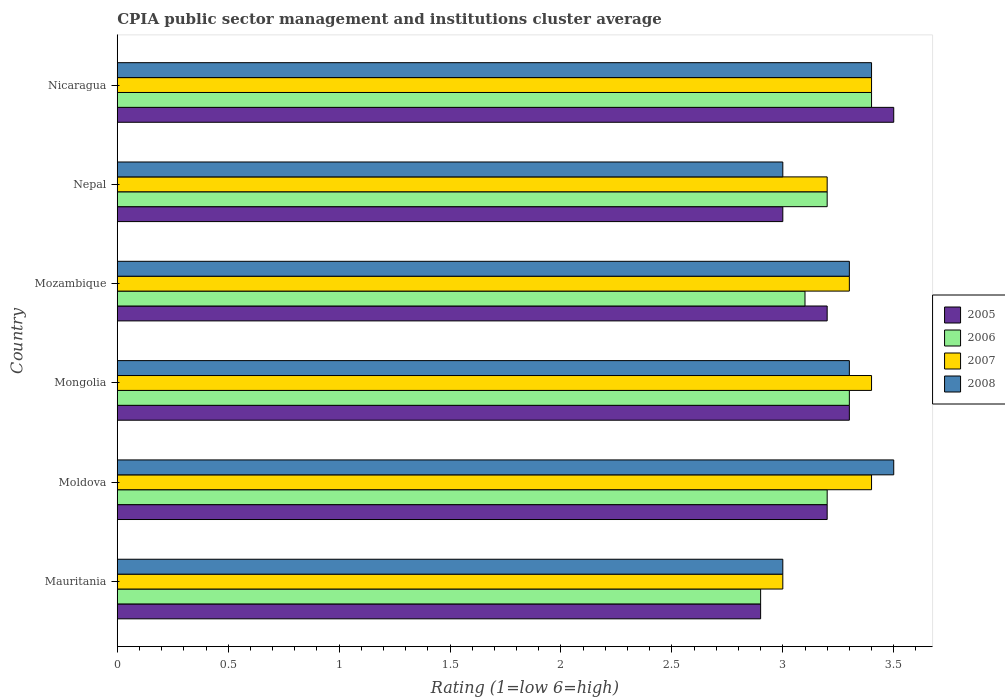How many different coloured bars are there?
Give a very brief answer. 4. Are the number of bars per tick equal to the number of legend labels?
Keep it short and to the point. Yes. Are the number of bars on each tick of the Y-axis equal?
Keep it short and to the point. Yes. How many bars are there on the 6th tick from the top?
Provide a succinct answer. 4. What is the label of the 1st group of bars from the top?
Offer a very short reply. Nicaragua. What is the CPIA rating in 2008 in Mozambique?
Make the answer very short. 3.3. Across all countries, what is the maximum CPIA rating in 2006?
Your answer should be very brief. 3.4. In which country was the CPIA rating in 2008 maximum?
Offer a terse response. Moldova. In which country was the CPIA rating in 2005 minimum?
Offer a terse response. Mauritania. What is the total CPIA rating in 2005 in the graph?
Keep it short and to the point. 19.1. What is the difference between the CPIA rating in 2008 in Mozambique and the CPIA rating in 2007 in Mauritania?
Give a very brief answer. 0.3. What is the average CPIA rating in 2006 per country?
Ensure brevity in your answer.  3.18. What is the ratio of the CPIA rating in 2006 in Moldova to that in Nicaragua?
Offer a very short reply. 0.94. Is it the case that in every country, the sum of the CPIA rating in 2005 and CPIA rating in 2008 is greater than the sum of CPIA rating in 2007 and CPIA rating in 2006?
Ensure brevity in your answer.  No. Is it the case that in every country, the sum of the CPIA rating in 2007 and CPIA rating in 2008 is greater than the CPIA rating in 2005?
Make the answer very short. Yes. Are the values on the major ticks of X-axis written in scientific E-notation?
Ensure brevity in your answer.  No. Does the graph contain any zero values?
Provide a succinct answer. No. How many legend labels are there?
Your answer should be compact. 4. How are the legend labels stacked?
Keep it short and to the point. Vertical. What is the title of the graph?
Give a very brief answer. CPIA public sector management and institutions cluster average. What is the label or title of the X-axis?
Your response must be concise. Rating (1=low 6=high). What is the label or title of the Y-axis?
Provide a short and direct response. Country. What is the Rating (1=low 6=high) of 2005 in Moldova?
Give a very brief answer. 3.2. What is the Rating (1=low 6=high) in 2007 in Moldova?
Ensure brevity in your answer.  3.4. What is the Rating (1=low 6=high) in 2005 in Mongolia?
Make the answer very short. 3.3. What is the Rating (1=low 6=high) in 2006 in Mongolia?
Give a very brief answer. 3.3. What is the Rating (1=low 6=high) in 2005 in Mozambique?
Provide a short and direct response. 3.2. What is the Rating (1=low 6=high) of 2007 in Mozambique?
Give a very brief answer. 3.3. What is the Rating (1=low 6=high) of 2005 in Nepal?
Keep it short and to the point. 3. What is the Rating (1=low 6=high) of 2006 in Nepal?
Make the answer very short. 3.2. What is the Rating (1=low 6=high) of 2007 in Nepal?
Your answer should be very brief. 3.2. What is the Rating (1=low 6=high) in 2008 in Nepal?
Offer a very short reply. 3. What is the Rating (1=low 6=high) in 2007 in Nicaragua?
Make the answer very short. 3.4. What is the Rating (1=low 6=high) in 2008 in Nicaragua?
Offer a very short reply. 3.4. Across all countries, what is the maximum Rating (1=low 6=high) of 2005?
Offer a very short reply. 3.5. Across all countries, what is the maximum Rating (1=low 6=high) in 2006?
Ensure brevity in your answer.  3.4. Across all countries, what is the maximum Rating (1=low 6=high) in 2007?
Your answer should be very brief. 3.4. Across all countries, what is the minimum Rating (1=low 6=high) in 2005?
Provide a short and direct response. 2.9. Across all countries, what is the minimum Rating (1=low 6=high) of 2006?
Make the answer very short. 2.9. What is the total Rating (1=low 6=high) of 2007 in the graph?
Your answer should be very brief. 19.7. What is the total Rating (1=low 6=high) of 2008 in the graph?
Give a very brief answer. 19.5. What is the difference between the Rating (1=low 6=high) in 2007 in Mauritania and that in Moldova?
Ensure brevity in your answer.  -0.4. What is the difference between the Rating (1=low 6=high) in 2005 in Mauritania and that in Mongolia?
Ensure brevity in your answer.  -0.4. What is the difference between the Rating (1=low 6=high) of 2006 in Mauritania and that in Mongolia?
Your response must be concise. -0.4. What is the difference between the Rating (1=low 6=high) of 2008 in Mauritania and that in Mozambique?
Offer a terse response. -0.3. What is the difference between the Rating (1=low 6=high) of 2005 in Mauritania and that in Nepal?
Your answer should be very brief. -0.1. What is the difference between the Rating (1=low 6=high) of 2006 in Mauritania and that in Nicaragua?
Provide a succinct answer. -0.5. What is the difference between the Rating (1=low 6=high) in 2007 in Mauritania and that in Nicaragua?
Give a very brief answer. -0.4. What is the difference between the Rating (1=low 6=high) of 2008 in Mauritania and that in Nicaragua?
Offer a very short reply. -0.4. What is the difference between the Rating (1=low 6=high) in 2005 in Moldova and that in Mongolia?
Your response must be concise. -0.1. What is the difference between the Rating (1=low 6=high) of 2006 in Moldova and that in Mongolia?
Offer a terse response. -0.1. What is the difference between the Rating (1=low 6=high) of 2007 in Moldova and that in Mongolia?
Provide a succinct answer. 0. What is the difference between the Rating (1=low 6=high) in 2005 in Moldova and that in Mozambique?
Keep it short and to the point. 0. What is the difference between the Rating (1=low 6=high) of 2008 in Moldova and that in Mozambique?
Give a very brief answer. 0.2. What is the difference between the Rating (1=low 6=high) of 2005 in Moldova and that in Nicaragua?
Provide a succinct answer. -0.3. What is the difference between the Rating (1=low 6=high) in 2006 in Moldova and that in Nicaragua?
Offer a very short reply. -0.2. What is the difference between the Rating (1=low 6=high) in 2007 in Moldova and that in Nicaragua?
Offer a very short reply. 0. What is the difference between the Rating (1=low 6=high) of 2005 in Mongolia and that in Mozambique?
Your answer should be very brief. 0.1. What is the difference between the Rating (1=low 6=high) of 2007 in Mongolia and that in Mozambique?
Provide a succinct answer. 0.1. What is the difference between the Rating (1=low 6=high) in 2008 in Mongolia and that in Mozambique?
Make the answer very short. 0. What is the difference between the Rating (1=low 6=high) of 2005 in Mongolia and that in Nepal?
Provide a succinct answer. 0.3. What is the difference between the Rating (1=low 6=high) in 2008 in Mongolia and that in Nepal?
Keep it short and to the point. 0.3. What is the difference between the Rating (1=low 6=high) in 2006 in Mongolia and that in Nicaragua?
Provide a short and direct response. -0.1. What is the difference between the Rating (1=low 6=high) of 2007 in Mongolia and that in Nicaragua?
Keep it short and to the point. 0. What is the difference between the Rating (1=low 6=high) in 2008 in Mongolia and that in Nicaragua?
Keep it short and to the point. -0.1. What is the difference between the Rating (1=low 6=high) in 2005 in Mozambique and that in Nepal?
Your answer should be very brief. 0.2. What is the difference between the Rating (1=low 6=high) of 2006 in Mozambique and that in Nepal?
Your response must be concise. -0.1. What is the difference between the Rating (1=low 6=high) of 2007 in Mozambique and that in Nepal?
Offer a terse response. 0.1. What is the difference between the Rating (1=low 6=high) in 2008 in Mozambique and that in Nepal?
Your answer should be compact. 0.3. What is the difference between the Rating (1=low 6=high) in 2008 in Nepal and that in Nicaragua?
Your response must be concise. -0.4. What is the difference between the Rating (1=low 6=high) of 2006 in Mauritania and the Rating (1=low 6=high) of 2007 in Moldova?
Your answer should be very brief. -0.5. What is the difference between the Rating (1=low 6=high) in 2006 in Mauritania and the Rating (1=low 6=high) in 2008 in Moldova?
Provide a succinct answer. -0.6. What is the difference between the Rating (1=low 6=high) in 2005 in Mauritania and the Rating (1=low 6=high) in 2008 in Mongolia?
Make the answer very short. -0.4. What is the difference between the Rating (1=low 6=high) in 2005 in Mauritania and the Rating (1=low 6=high) in 2008 in Mozambique?
Provide a succinct answer. -0.4. What is the difference between the Rating (1=low 6=high) in 2006 in Mauritania and the Rating (1=low 6=high) in 2007 in Mozambique?
Provide a succinct answer. -0.4. What is the difference between the Rating (1=low 6=high) of 2007 in Mauritania and the Rating (1=low 6=high) of 2008 in Mozambique?
Offer a terse response. -0.3. What is the difference between the Rating (1=low 6=high) of 2005 in Mauritania and the Rating (1=low 6=high) of 2008 in Nepal?
Give a very brief answer. -0.1. What is the difference between the Rating (1=low 6=high) of 2006 in Mauritania and the Rating (1=low 6=high) of 2007 in Nepal?
Your answer should be compact. -0.3. What is the difference between the Rating (1=low 6=high) of 2007 in Mauritania and the Rating (1=low 6=high) of 2008 in Nepal?
Offer a very short reply. 0. What is the difference between the Rating (1=low 6=high) in 2005 in Mauritania and the Rating (1=low 6=high) in 2008 in Nicaragua?
Offer a terse response. -0.5. What is the difference between the Rating (1=low 6=high) of 2006 in Mauritania and the Rating (1=low 6=high) of 2007 in Nicaragua?
Keep it short and to the point. -0.5. What is the difference between the Rating (1=low 6=high) of 2006 in Mauritania and the Rating (1=low 6=high) of 2008 in Nicaragua?
Provide a short and direct response. -0.5. What is the difference between the Rating (1=low 6=high) in 2007 in Mauritania and the Rating (1=low 6=high) in 2008 in Nicaragua?
Provide a succinct answer. -0.4. What is the difference between the Rating (1=low 6=high) in 2005 in Moldova and the Rating (1=low 6=high) in 2007 in Mongolia?
Offer a very short reply. -0.2. What is the difference between the Rating (1=low 6=high) in 2007 in Moldova and the Rating (1=low 6=high) in 2008 in Mongolia?
Offer a very short reply. 0.1. What is the difference between the Rating (1=low 6=high) in 2005 in Moldova and the Rating (1=low 6=high) in 2007 in Mozambique?
Your answer should be compact. -0.1. What is the difference between the Rating (1=low 6=high) in 2007 in Moldova and the Rating (1=low 6=high) in 2008 in Mozambique?
Offer a terse response. 0.1. What is the difference between the Rating (1=low 6=high) in 2005 in Moldova and the Rating (1=low 6=high) in 2007 in Nepal?
Offer a terse response. 0. What is the difference between the Rating (1=low 6=high) in 2005 in Moldova and the Rating (1=low 6=high) in 2008 in Nepal?
Offer a terse response. 0.2. What is the difference between the Rating (1=low 6=high) of 2006 in Moldova and the Rating (1=low 6=high) of 2007 in Nepal?
Give a very brief answer. 0. What is the difference between the Rating (1=low 6=high) of 2005 in Moldova and the Rating (1=low 6=high) of 2007 in Nicaragua?
Provide a succinct answer. -0.2. What is the difference between the Rating (1=low 6=high) in 2006 in Moldova and the Rating (1=low 6=high) in 2007 in Nicaragua?
Your answer should be very brief. -0.2. What is the difference between the Rating (1=low 6=high) of 2007 in Moldova and the Rating (1=low 6=high) of 2008 in Nicaragua?
Offer a very short reply. 0. What is the difference between the Rating (1=low 6=high) in 2005 in Mongolia and the Rating (1=low 6=high) in 2006 in Mozambique?
Your answer should be very brief. 0.2. What is the difference between the Rating (1=low 6=high) of 2005 in Mongolia and the Rating (1=low 6=high) of 2008 in Mozambique?
Your response must be concise. 0. What is the difference between the Rating (1=low 6=high) of 2006 in Mongolia and the Rating (1=low 6=high) of 2007 in Mozambique?
Your response must be concise. 0. What is the difference between the Rating (1=low 6=high) in 2006 in Mongolia and the Rating (1=low 6=high) in 2008 in Mozambique?
Your answer should be very brief. 0. What is the difference between the Rating (1=low 6=high) of 2007 in Mongolia and the Rating (1=low 6=high) of 2008 in Mozambique?
Your answer should be very brief. 0.1. What is the difference between the Rating (1=low 6=high) of 2005 in Mongolia and the Rating (1=low 6=high) of 2007 in Nepal?
Your response must be concise. 0.1. What is the difference between the Rating (1=low 6=high) of 2007 in Mongolia and the Rating (1=low 6=high) of 2008 in Nepal?
Provide a succinct answer. 0.4. What is the difference between the Rating (1=low 6=high) in 2005 in Mongolia and the Rating (1=low 6=high) in 2006 in Nicaragua?
Provide a short and direct response. -0.1. What is the difference between the Rating (1=low 6=high) of 2005 in Mongolia and the Rating (1=low 6=high) of 2007 in Nicaragua?
Your response must be concise. -0.1. What is the difference between the Rating (1=low 6=high) of 2005 in Mozambique and the Rating (1=low 6=high) of 2006 in Nepal?
Your response must be concise. 0. What is the difference between the Rating (1=low 6=high) in 2005 in Mozambique and the Rating (1=low 6=high) in 2008 in Nepal?
Your answer should be very brief. 0.2. What is the difference between the Rating (1=low 6=high) of 2006 in Mozambique and the Rating (1=low 6=high) of 2007 in Nepal?
Ensure brevity in your answer.  -0.1. What is the difference between the Rating (1=low 6=high) of 2006 in Mozambique and the Rating (1=low 6=high) of 2008 in Nepal?
Your response must be concise. 0.1. What is the difference between the Rating (1=low 6=high) of 2007 in Mozambique and the Rating (1=low 6=high) of 2008 in Nepal?
Your response must be concise. 0.3. What is the difference between the Rating (1=low 6=high) in 2005 in Mozambique and the Rating (1=low 6=high) in 2006 in Nicaragua?
Offer a very short reply. -0.2. What is the difference between the Rating (1=low 6=high) in 2005 in Mozambique and the Rating (1=low 6=high) in 2008 in Nicaragua?
Give a very brief answer. -0.2. What is the difference between the Rating (1=low 6=high) of 2006 in Mozambique and the Rating (1=low 6=high) of 2007 in Nicaragua?
Make the answer very short. -0.3. What is the difference between the Rating (1=low 6=high) of 2006 in Mozambique and the Rating (1=low 6=high) of 2008 in Nicaragua?
Ensure brevity in your answer.  -0.3. What is the difference between the Rating (1=low 6=high) in 2005 in Nepal and the Rating (1=low 6=high) in 2006 in Nicaragua?
Your response must be concise. -0.4. What is the difference between the Rating (1=low 6=high) of 2005 in Nepal and the Rating (1=low 6=high) of 2007 in Nicaragua?
Keep it short and to the point. -0.4. What is the difference between the Rating (1=low 6=high) of 2006 in Nepal and the Rating (1=low 6=high) of 2008 in Nicaragua?
Your response must be concise. -0.2. What is the difference between the Rating (1=low 6=high) in 2007 in Nepal and the Rating (1=low 6=high) in 2008 in Nicaragua?
Provide a short and direct response. -0.2. What is the average Rating (1=low 6=high) of 2005 per country?
Keep it short and to the point. 3.18. What is the average Rating (1=low 6=high) in 2006 per country?
Keep it short and to the point. 3.18. What is the average Rating (1=low 6=high) in 2007 per country?
Give a very brief answer. 3.28. What is the difference between the Rating (1=low 6=high) of 2005 and Rating (1=low 6=high) of 2006 in Mauritania?
Provide a succinct answer. 0. What is the difference between the Rating (1=low 6=high) in 2005 and Rating (1=low 6=high) in 2007 in Mauritania?
Provide a short and direct response. -0.1. What is the difference between the Rating (1=low 6=high) in 2006 and Rating (1=low 6=high) in 2007 in Mauritania?
Your answer should be very brief. -0.1. What is the difference between the Rating (1=low 6=high) of 2005 and Rating (1=low 6=high) of 2007 in Moldova?
Your response must be concise. -0.2. What is the difference between the Rating (1=low 6=high) of 2006 and Rating (1=low 6=high) of 2007 in Moldova?
Give a very brief answer. -0.2. What is the difference between the Rating (1=low 6=high) of 2006 and Rating (1=low 6=high) of 2008 in Moldova?
Keep it short and to the point. -0.3. What is the difference between the Rating (1=low 6=high) of 2005 and Rating (1=low 6=high) of 2006 in Mongolia?
Provide a short and direct response. 0. What is the difference between the Rating (1=low 6=high) of 2005 and Rating (1=low 6=high) of 2007 in Mongolia?
Provide a succinct answer. -0.1. What is the difference between the Rating (1=low 6=high) in 2006 and Rating (1=low 6=high) in 2008 in Mongolia?
Your response must be concise. 0. What is the difference between the Rating (1=low 6=high) in 2007 and Rating (1=low 6=high) in 2008 in Mongolia?
Your answer should be compact. 0.1. What is the difference between the Rating (1=low 6=high) in 2005 and Rating (1=low 6=high) in 2006 in Mozambique?
Give a very brief answer. 0.1. What is the difference between the Rating (1=low 6=high) of 2005 and Rating (1=low 6=high) of 2007 in Mozambique?
Offer a terse response. -0.1. What is the difference between the Rating (1=low 6=high) of 2005 and Rating (1=low 6=high) of 2008 in Mozambique?
Offer a terse response. -0.1. What is the difference between the Rating (1=low 6=high) in 2005 and Rating (1=low 6=high) in 2006 in Nepal?
Offer a terse response. -0.2. What is the difference between the Rating (1=low 6=high) in 2005 and Rating (1=low 6=high) in 2007 in Nepal?
Ensure brevity in your answer.  -0.2. What is the difference between the Rating (1=low 6=high) of 2006 and Rating (1=low 6=high) of 2007 in Nepal?
Provide a succinct answer. 0. What is the difference between the Rating (1=low 6=high) in 2007 and Rating (1=low 6=high) in 2008 in Nepal?
Offer a terse response. 0.2. What is the difference between the Rating (1=low 6=high) in 2005 and Rating (1=low 6=high) in 2007 in Nicaragua?
Keep it short and to the point. 0.1. What is the difference between the Rating (1=low 6=high) in 2005 and Rating (1=low 6=high) in 2008 in Nicaragua?
Ensure brevity in your answer.  0.1. What is the ratio of the Rating (1=low 6=high) of 2005 in Mauritania to that in Moldova?
Offer a very short reply. 0.91. What is the ratio of the Rating (1=low 6=high) in 2006 in Mauritania to that in Moldova?
Ensure brevity in your answer.  0.91. What is the ratio of the Rating (1=low 6=high) in 2007 in Mauritania to that in Moldova?
Make the answer very short. 0.88. What is the ratio of the Rating (1=low 6=high) in 2008 in Mauritania to that in Moldova?
Give a very brief answer. 0.86. What is the ratio of the Rating (1=low 6=high) in 2005 in Mauritania to that in Mongolia?
Your answer should be very brief. 0.88. What is the ratio of the Rating (1=low 6=high) in 2006 in Mauritania to that in Mongolia?
Your answer should be very brief. 0.88. What is the ratio of the Rating (1=low 6=high) in 2007 in Mauritania to that in Mongolia?
Make the answer very short. 0.88. What is the ratio of the Rating (1=low 6=high) in 2008 in Mauritania to that in Mongolia?
Keep it short and to the point. 0.91. What is the ratio of the Rating (1=low 6=high) of 2005 in Mauritania to that in Mozambique?
Give a very brief answer. 0.91. What is the ratio of the Rating (1=low 6=high) in 2006 in Mauritania to that in Mozambique?
Offer a very short reply. 0.94. What is the ratio of the Rating (1=low 6=high) in 2008 in Mauritania to that in Mozambique?
Keep it short and to the point. 0.91. What is the ratio of the Rating (1=low 6=high) of 2005 in Mauritania to that in Nepal?
Provide a short and direct response. 0.97. What is the ratio of the Rating (1=low 6=high) in 2006 in Mauritania to that in Nepal?
Give a very brief answer. 0.91. What is the ratio of the Rating (1=low 6=high) in 2007 in Mauritania to that in Nepal?
Offer a terse response. 0.94. What is the ratio of the Rating (1=low 6=high) of 2008 in Mauritania to that in Nepal?
Give a very brief answer. 1. What is the ratio of the Rating (1=low 6=high) in 2005 in Mauritania to that in Nicaragua?
Your answer should be very brief. 0.83. What is the ratio of the Rating (1=low 6=high) of 2006 in Mauritania to that in Nicaragua?
Make the answer very short. 0.85. What is the ratio of the Rating (1=low 6=high) of 2007 in Mauritania to that in Nicaragua?
Ensure brevity in your answer.  0.88. What is the ratio of the Rating (1=low 6=high) in 2008 in Mauritania to that in Nicaragua?
Give a very brief answer. 0.88. What is the ratio of the Rating (1=low 6=high) in 2005 in Moldova to that in Mongolia?
Ensure brevity in your answer.  0.97. What is the ratio of the Rating (1=low 6=high) in 2006 in Moldova to that in Mongolia?
Offer a very short reply. 0.97. What is the ratio of the Rating (1=low 6=high) of 2007 in Moldova to that in Mongolia?
Offer a terse response. 1. What is the ratio of the Rating (1=low 6=high) of 2008 in Moldova to that in Mongolia?
Your answer should be compact. 1.06. What is the ratio of the Rating (1=low 6=high) of 2005 in Moldova to that in Mozambique?
Offer a terse response. 1. What is the ratio of the Rating (1=low 6=high) in 2006 in Moldova to that in Mozambique?
Ensure brevity in your answer.  1.03. What is the ratio of the Rating (1=low 6=high) in 2007 in Moldova to that in Mozambique?
Keep it short and to the point. 1.03. What is the ratio of the Rating (1=low 6=high) in 2008 in Moldova to that in Mozambique?
Your response must be concise. 1.06. What is the ratio of the Rating (1=low 6=high) in 2005 in Moldova to that in Nepal?
Offer a terse response. 1.07. What is the ratio of the Rating (1=low 6=high) in 2006 in Moldova to that in Nepal?
Your answer should be compact. 1. What is the ratio of the Rating (1=low 6=high) in 2005 in Moldova to that in Nicaragua?
Your answer should be compact. 0.91. What is the ratio of the Rating (1=low 6=high) of 2006 in Moldova to that in Nicaragua?
Your answer should be compact. 0.94. What is the ratio of the Rating (1=low 6=high) in 2007 in Moldova to that in Nicaragua?
Your response must be concise. 1. What is the ratio of the Rating (1=low 6=high) in 2008 in Moldova to that in Nicaragua?
Give a very brief answer. 1.03. What is the ratio of the Rating (1=low 6=high) in 2005 in Mongolia to that in Mozambique?
Your response must be concise. 1.03. What is the ratio of the Rating (1=low 6=high) in 2006 in Mongolia to that in Mozambique?
Give a very brief answer. 1.06. What is the ratio of the Rating (1=low 6=high) in 2007 in Mongolia to that in Mozambique?
Make the answer very short. 1.03. What is the ratio of the Rating (1=low 6=high) of 2005 in Mongolia to that in Nepal?
Your answer should be very brief. 1.1. What is the ratio of the Rating (1=low 6=high) in 2006 in Mongolia to that in Nepal?
Your answer should be compact. 1.03. What is the ratio of the Rating (1=low 6=high) of 2007 in Mongolia to that in Nepal?
Give a very brief answer. 1.06. What is the ratio of the Rating (1=low 6=high) of 2005 in Mongolia to that in Nicaragua?
Your answer should be compact. 0.94. What is the ratio of the Rating (1=low 6=high) in 2006 in Mongolia to that in Nicaragua?
Provide a succinct answer. 0.97. What is the ratio of the Rating (1=low 6=high) in 2007 in Mongolia to that in Nicaragua?
Ensure brevity in your answer.  1. What is the ratio of the Rating (1=low 6=high) in 2008 in Mongolia to that in Nicaragua?
Your answer should be very brief. 0.97. What is the ratio of the Rating (1=low 6=high) of 2005 in Mozambique to that in Nepal?
Give a very brief answer. 1.07. What is the ratio of the Rating (1=low 6=high) of 2006 in Mozambique to that in Nepal?
Provide a succinct answer. 0.97. What is the ratio of the Rating (1=low 6=high) in 2007 in Mozambique to that in Nepal?
Offer a terse response. 1.03. What is the ratio of the Rating (1=low 6=high) in 2008 in Mozambique to that in Nepal?
Offer a very short reply. 1.1. What is the ratio of the Rating (1=low 6=high) in 2005 in Mozambique to that in Nicaragua?
Offer a terse response. 0.91. What is the ratio of the Rating (1=low 6=high) of 2006 in Mozambique to that in Nicaragua?
Provide a short and direct response. 0.91. What is the ratio of the Rating (1=low 6=high) of 2007 in Mozambique to that in Nicaragua?
Provide a succinct answer. 0.97. What is the ratio of the Rating (1=low 6=high) in 2008 in Mozambique to that in Nicaragua?
Provide a succinct answer. 0.97. What is the ratio of the Rating (1=low 6=high) of 2006 in Nepal to that in Nicaragua?
Make the answer very short. 0.94. What is the ratio of the Rating (1=low 6=high) of 2008 in Nepal to that in Nicaragua?
Provide a succinct answer. 0.88. What is the difference between the highest and the second highest Rating (1=low 6=high) of 2006?
Provide a succinct answer. 0.1. What is the difference between the highest and the second highest Rating (1=low 6=high) of 2007?
Provide a short and direct response. 0. What is the difference between the highest and the second highest Rating (1=low 6=high) in 2008?
Your answer should be compact. 0.1. What is the difference between the highest and the lowest Rating (1=low 6=high) in 2005?
Make the answer very short. 0.6. 